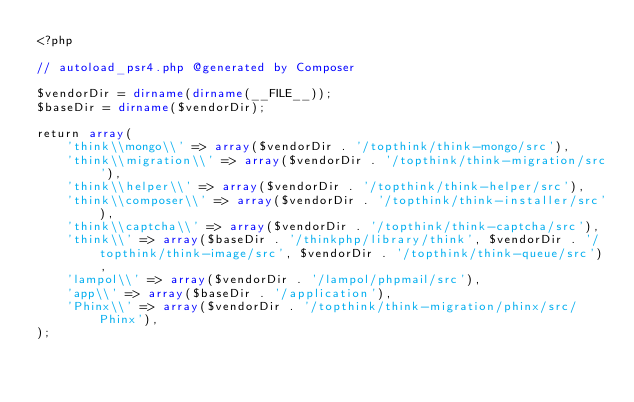<code> <loc_0><loc_0><loc_500><loc_500><_PHP_><?php

// autoload_psr4.php @generated by Composer

$vendorDir = dirname(dirname(__FILE__));
$baseDir = dirname($vendorDir);

return array(
    'think\\mongo\\' => array($vendorDir . '/topthink/think-mongo/src'),
    'think\\migration\\' => array($vendorDir . '/topthink/think-migration/src'),
    'think\\helper\\' => array($vendorDir . '/topthink/think-helper/src'),
    'think\\composer\\' => array($vendorDir . '/topthink/think-installer/src'),
    'think\\captcha\\' => array($vendorDir . '/topthink/think-captcha/src'),
    'think\\' => array($baseDir . '/thinkphp/library/think', $vendorDir . '/topthink/think-image/src', $vendorDir . '/topthink/think-queue/src'),
    'lampol\\' => array($vendorDir . '/lampol/phpmail/src'),
    'app\\' => array($baseDir . '/application'),
    'Phinx\\' => array($vendorDir . '/topthink/think-migration/phinx/src/Phinx'),
);
</code> 